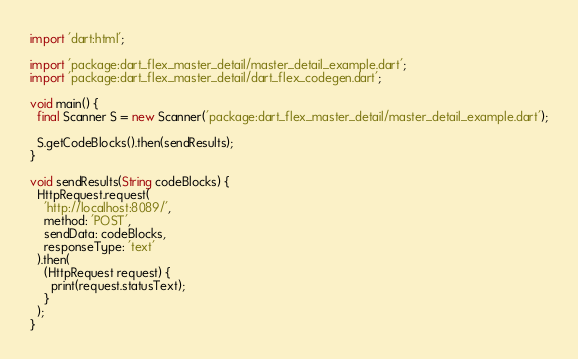<code> <loc_0><loc_0><loc_500><loc_500><_Dart_>import 'dart:html';

import 'package:dart_flex_master_detail/master_detail_example.dart';
import 'package:dart_flex_master_detail/dart_flex_codegen.dart';

void main() {
  final Scanner S = new Scanner('package:dart_flex_master_detail/master_detail_example.dart');
  
  S.getCodeBlocks().then(sendResults);
}

void sendResults(String codeBlocks) {
  HttpRequest.request(
    'http://localhost:8089/', 
    method: 'POST', 
    sendData: codeBlocks,
    responseType: 'text'
  ).then(
    (HttpRequest request) {
      print(request.statusText);
    }
  );
}














</code> 